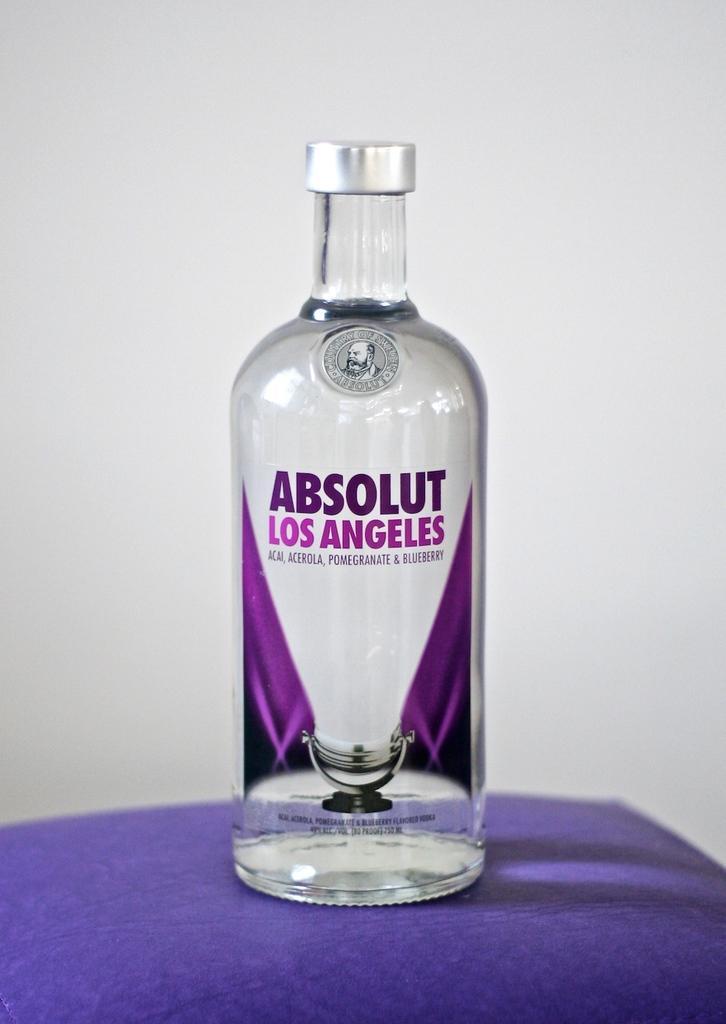Can you describe this image briefly? In the center of the image there is a beverage placed on the table. In the background there is a wall. 